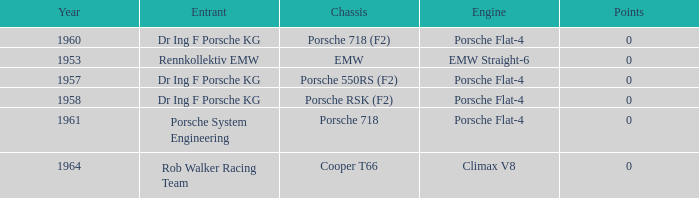Which engine did dr ing f porsche kg use with the porsche rsk (f2) chassis? Porsche Flat-4. 